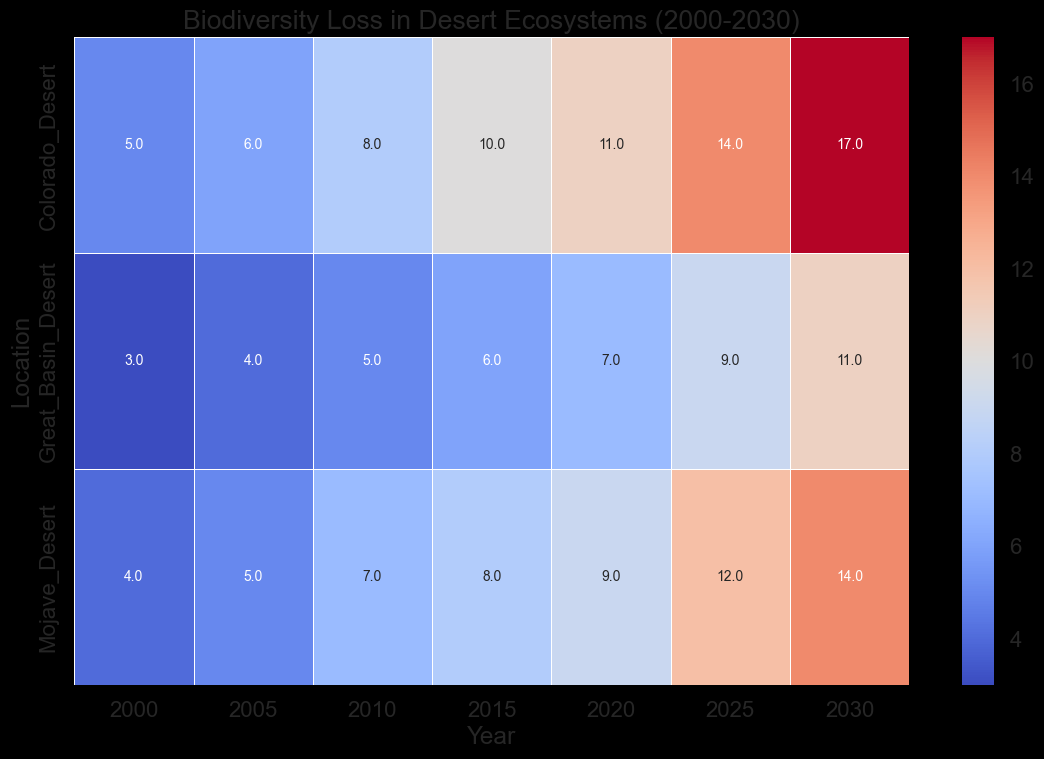What is the biodiversity loss in the Colorado Desert in the year 2020? In the heatmap, locate the Colorado Desert row and the column for the year 2020. The intersection shows the biodiversity loss value.
Answer: 11 Which desert had the highest biodiversity loss in the year 2025? Compare the biodiversity loss values among the Colorado Desert, Mojave Desert, and Great Basin Desert for the year 2025. The highest value will indicate the desert with the most loss.
Answer: Colorado Desert Between which years did the Colorado Desert experience the greatest increase in biodiversity loss? Calculate the differences in biodiversity loss between consecutive years for the Colorado Desert and identify the maximum difference. For instance, from 2000 to 2005, 5 to 6 is an increase of 1, from 2005 to 2010, 6 to 8 is an increase of 2, etc.
Answer: 2025 to 2030 Compare the biodiversity loss between the Mojave Desert and the Great Basin Desert in the year 2010. Which desert experienced higher loss? Check the values in the heatmap for the Mojave Desert and Great Basin Desert in the column for the year 2010 and compare them.
Answer: Mojave Desert By how much did the biodiversity loss in the Great Basin Desert increase from 2000 to 2030? Subtract the biodiversity loss value for the Great Basin Desert in 2000 from the value in 2030 (11 - 3).
Answer: 8 Which year had the smallest biodiversity loss in the Mojave Desert, and what was the value? Identify the lowest value in the row for Mojave Desert across all years in the heatmap.
Answer: 2000, 4 How does the biodiversity loss trend in the Colorado Desert compare to that in the Great Basin Desert over the years displayed? Examine the heatmap values across the years from 2000 to 2030 for both deserts. See if they both increase, decrease, or have differing trends.
Answer: Both show increasing trends What is the average biodiversity loss in the Mojave Desert across all years presented? Sum the biodiversity loss values for the Mojave Desert across all years and divide by the number of years (4 + 5 + 7 + 8 + 9 + 12 + 14) / 7.
Answer: 8.43 Which desert shows the most significant color change from 2005 to 2030, indicating a high biodiversity loss increase? Visually inspect the heatmap. The desert with the largest shift towards a more intense color (indicating higher values) from 2005 to 2030 shows the most significant increase.
Answer: Colorado Desert Are there any years where all deserts have the same biodiversity loss? Scan the columns in the heatmap to see if any year has the same value across all three deserts.
Answer: No 